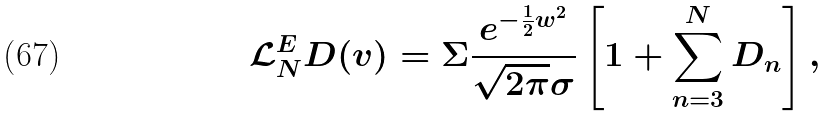Convert formula to latex. <formula><loc_0><loc_0><loc_500><loc_500>\mathcal { L } _ { N } ^ { E } D ( v ) = \Sigma \frac { e ^ { - \frac { 1 } { 2 } w ^ { 2 } } } { \sqrt { 2 \pi } \sigma } \left [ 1 + \sum _ { n = 3 } ^ { N } D _ { n } \right ] ,</formula> 